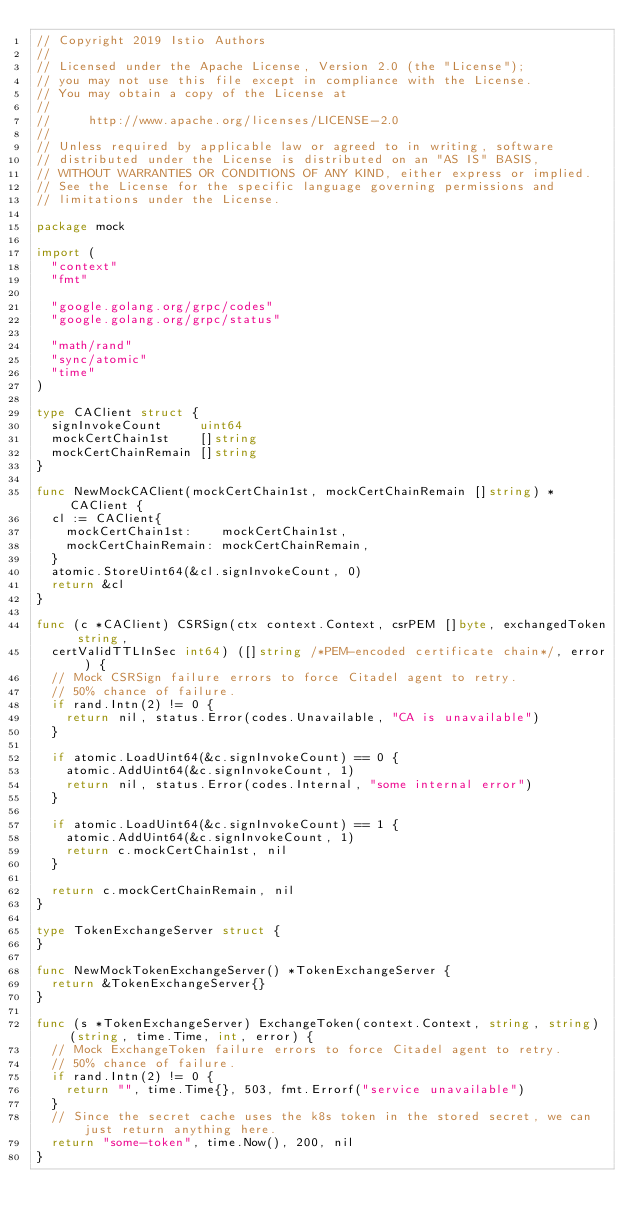Convert code to text. <code><loc_0><loc_0><loc_500><loc_500><_Go_>// Copyright 2019 Istio Authors
//
// Licensed under the Apache License, Version 2.0 (the "License");
// you may not use this file except in compliance with the License.
// You may obtain a copy of the License at
//
//     http://www.apache.org/licenses/LICENSE-2.0
//
// Unless required by applicable law or agreed to in writing, software
// distributed under the License is distributed on an "AS IS" BASIS,
// WITHOUT WARRANTIES OR CONDITIONS OF ANY KIND, either express or implied.
// See the License for the specific language governing permissions and
// limitations under the License.

package mock

import (
	"context"
	"fmt"

	"google.golang.org/grpc/codes"
	"google.golang.org/grpc/status"

	"math/rand"
	"sync/atomic"
	"time"
)

type CAClient struct {
	signInvokeCount     uint64
	mockCertChain1st    []string
	mockCertChainRemain []string
}

func NewMockCAClient(mockCertChain1st, mockCertChainRemain []string) *CAClient {
	cl := CAClient{
		mockCertChain1st:    mockCertChain1st,
		mockCertChainRemain: mockCertChainRemain,
	}
	atomic.StoreUint64(&cl.signInvokeCount, 0)
	return &cl
}

func (c *CAClient) CSRSign(ctx context.Context, csrPEM []byte, exchangedToken string,
	certValidTTLInSec int64) ([]string /*PEM-encoded certificate chain*/, error) {
	// Mock CSRSign failure errors to force Citadel agent to retry.
	// 50% chance of failure.
	if rand.Intn(2) != 0 {
		return nil, status.Error(codes.Unavailable, "CA is unavailable")
	}

	if atomic.LoadUint64(&c.signInvokeCount) == 0 {
		atomic.AddUint64(&c.signInvokeCount, 1)
		return nil, status.Error(codes.Internal, "some internal error")
	}

	if atomic.LoadUint64(&c.signInvokeCount) == 1 {
		atomic.AddUint64(&c.signInvokeCount, 1)
		return c.mockCertChain1st, nil
	}

	return c.mockCertChainRemain, nil
}

type TokenExchangeServer struct {
}

func NewMockTokenExchangeServer() *TokenExchangeServer {
	return &TokenExchangeServer{}
}

func (s *TokenExchangeServer) ExchangeToken(context.Context, string, string) (string, time.Time, int, error) {
	// Mock ExchangeToken failure errors to force Citadel agent to retry.
	// 50% chance of failure.
	if rand.Intn(2) != 0 {
		return "", time.Time{}, 503, fmt.Errorf("service unavailable")
	}
	// Since the secret cache uses the k8s token in the stored secret, we can just return anything here.
	return "some-token", time.Now(), 200, nil
}
</code> 